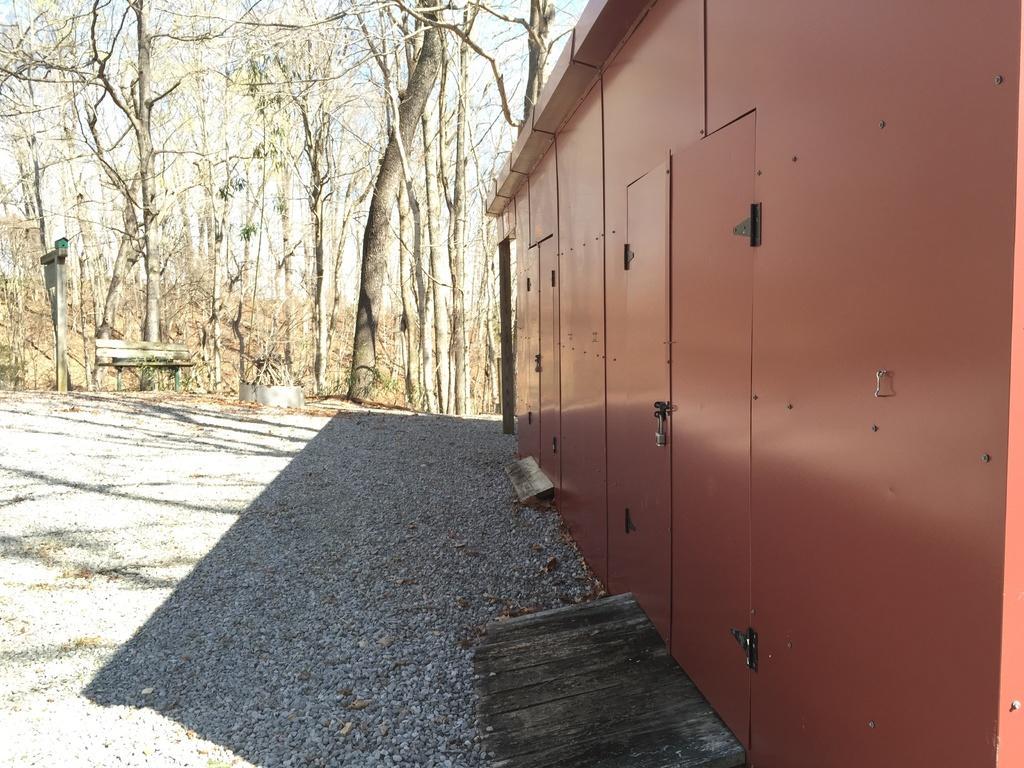In one or two sentences, can you explain what this image depicts? In this image, at the right side there is a brown color house and there are some doors to enter in it, at the background there are some trees. 